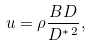<formula> <loc_0><loc_0><loc_500><loc_500>u = \rho \frac { B D } { D ^ { \ast \, 2 } } ,</formula> 